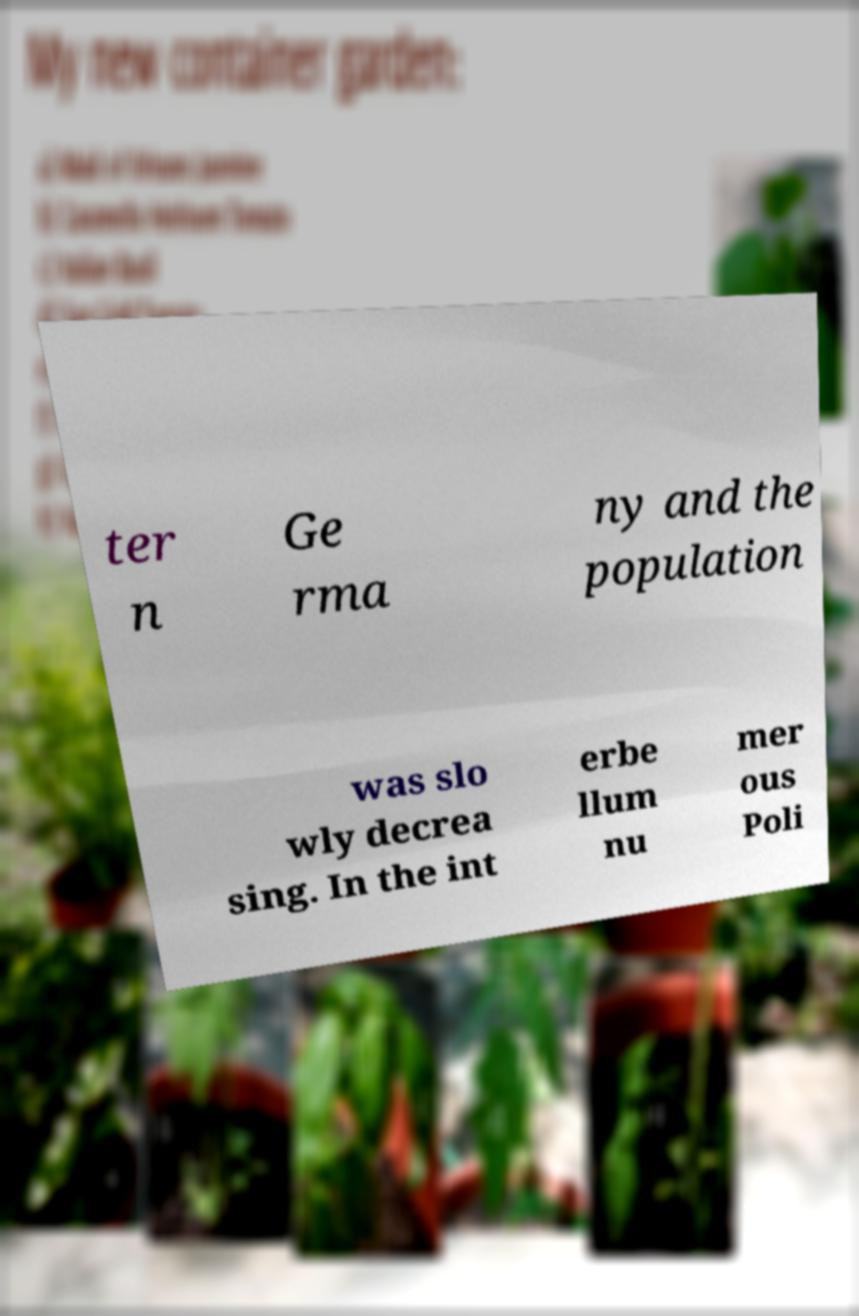I need the written content from this picture converted into text. Can you do that? ter n Ge rma ny and the population was slo wly decrea sing. In the int erbe llum nu mer ous Poli 